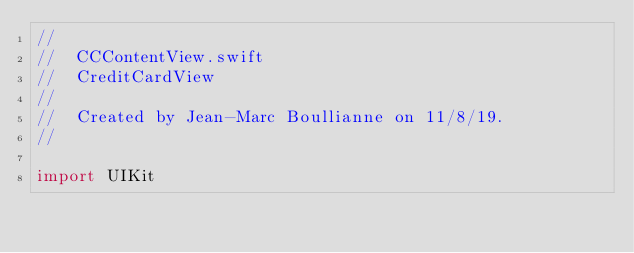Convert code to text. <code><loc_0><loc_0><loc_500><loc_500><_Swift_>//
//  CCContentView.swift
//  CreditCardView
//
//  Created by Jean-Marc Boullianne on 11/8/19.
//

import UIKit
</code> 